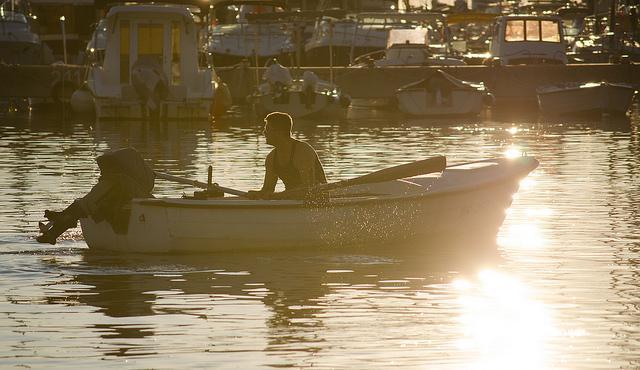How many boats can be seen?
Give a very brief answer. 9. How many black dog in the image?
Give a very brief answer. 0. 